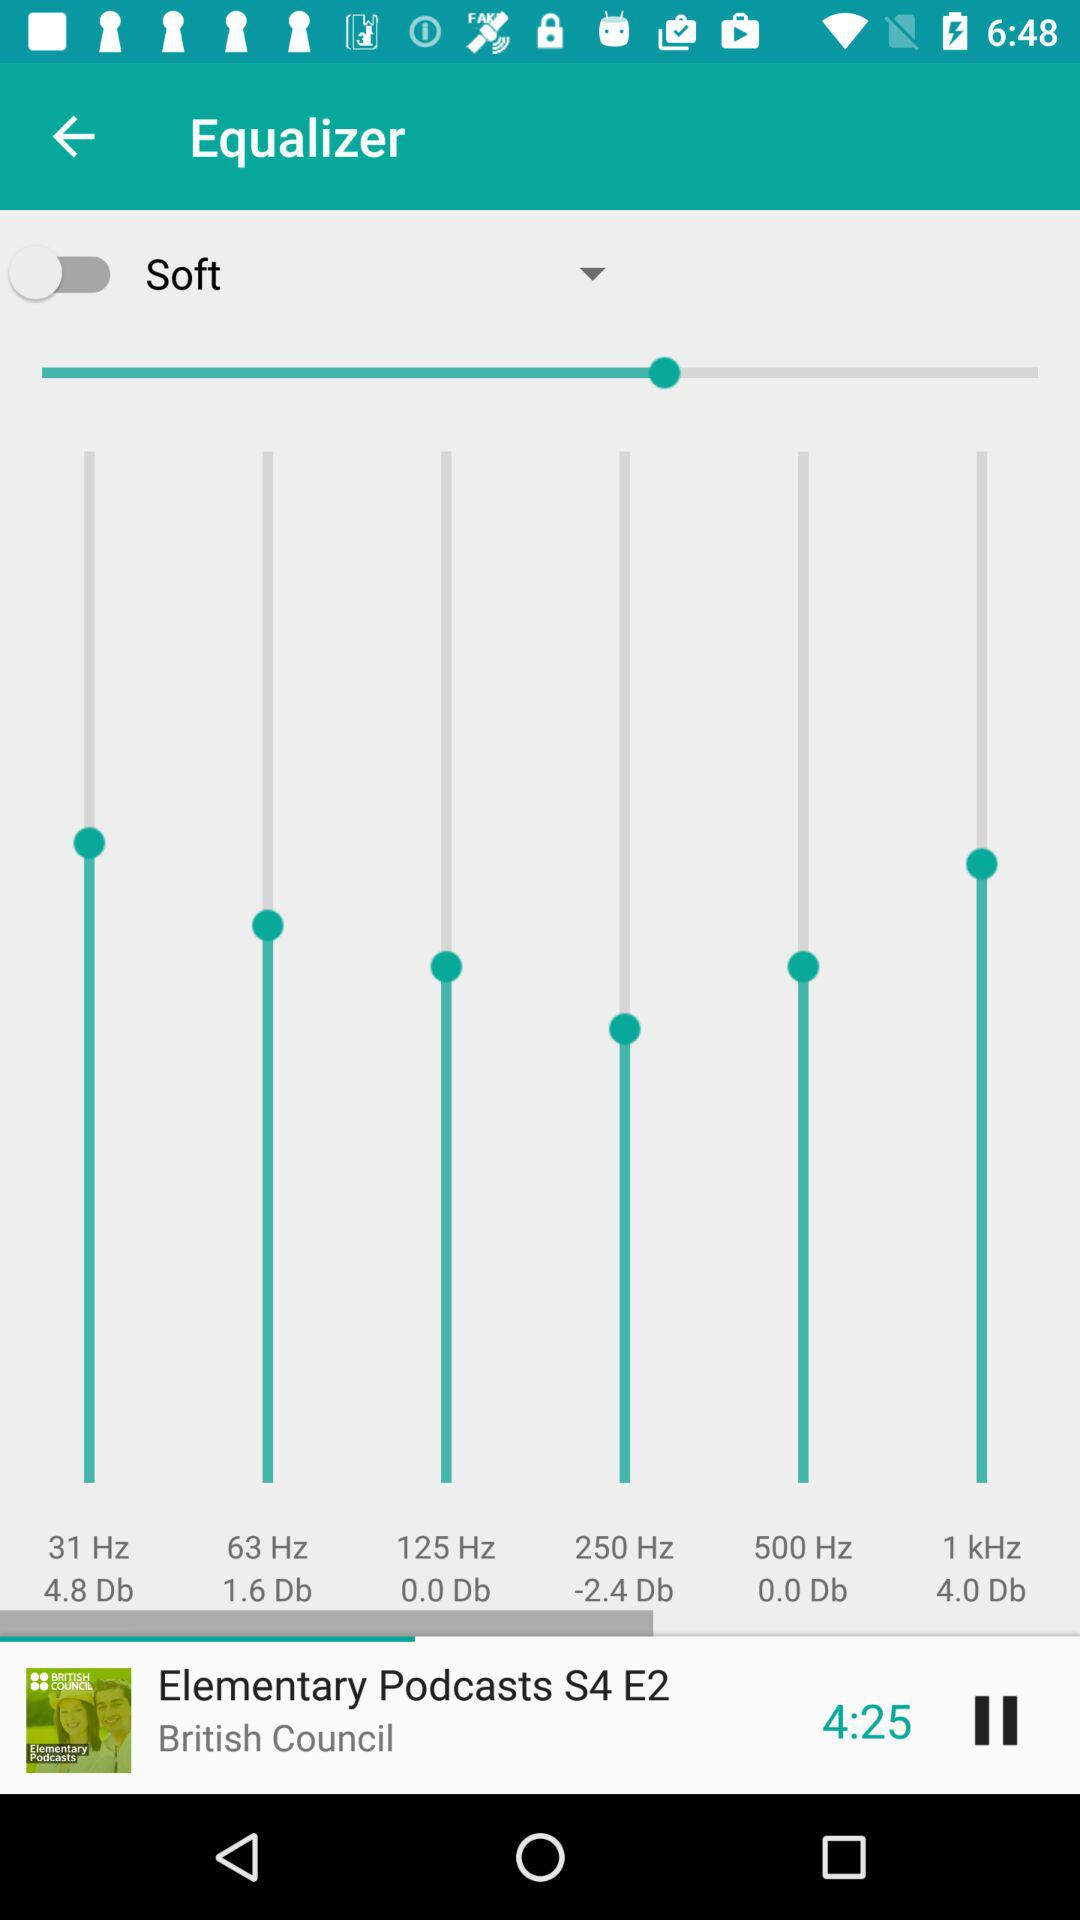Which episode of "Elementary Podcasts" is playing? The episode that is playing is "E2". 